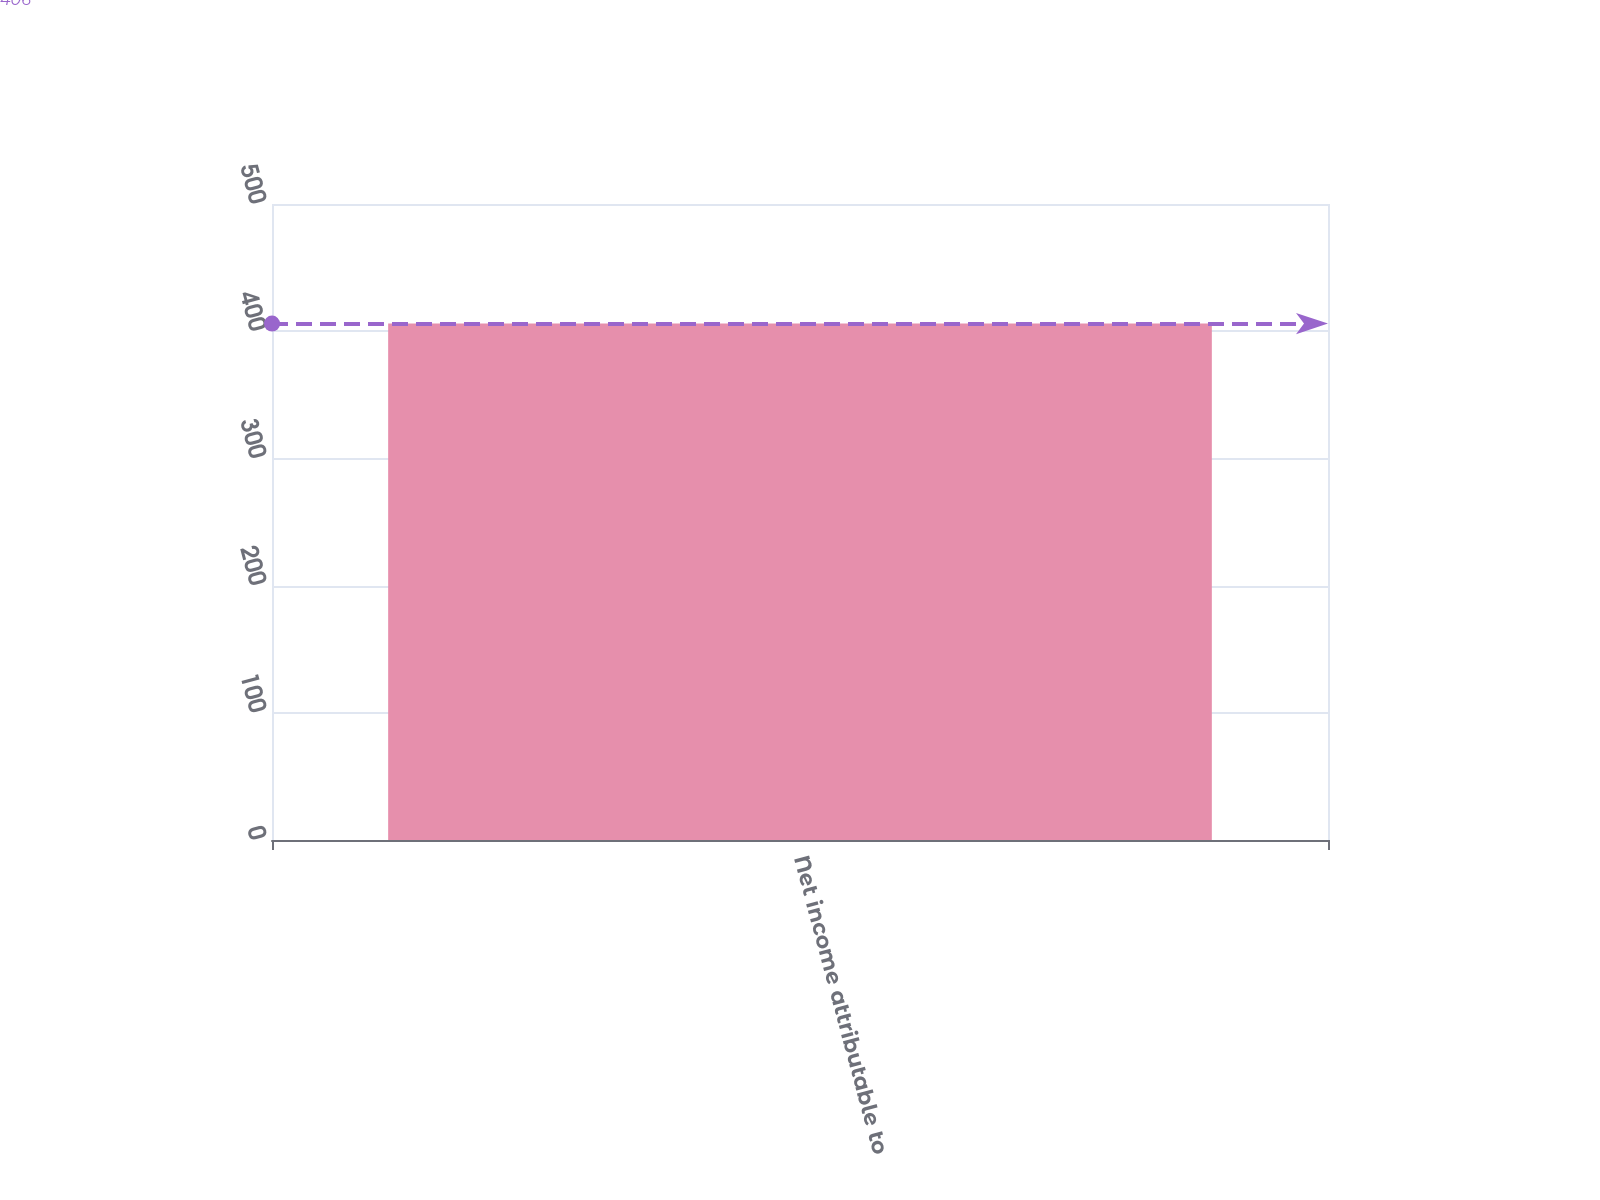Convert chart. <chart><loc_0><loc_0><loc_500><loc_500><bar_chart><fcel>Net income attributable to<nl><fcel>406<nl></chart> 